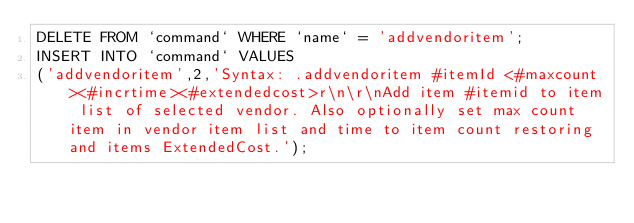<code> <loc_0><loc_0><loc_500><loc_500><_SQL_>DELETE FROM `command` WHERE `name` = 'addvendoritem';
INSERT INTO `command` VALUES
('addvendoritem',2,'Syntax: .addvendoritem #itemId <#maxcount><#incrtime><#extendedcost>r\n\r\nAdd item #itemid to item list of selected vendor. Also optionally set max count item in vendor item list and time to item count restoring and items ExtendedCost.');
</code> 